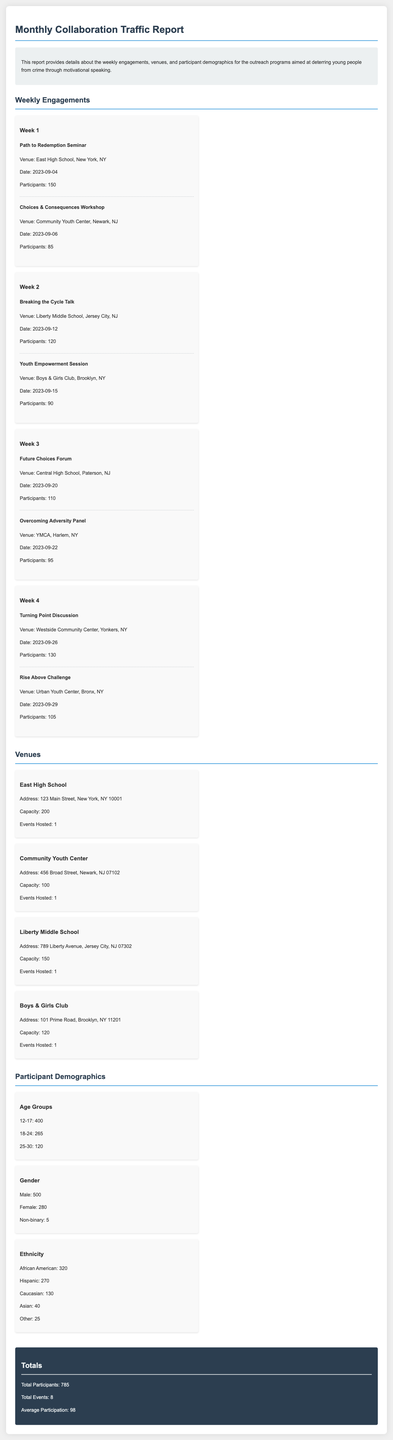What is the total number of participants? The total number of participants is summarized in the Totals section of the report.
Answer: 785 What workshop was held at Community Youth Center? The event name is listed under Week 1 of the Weekly Engagements section.
Answer: Choices & Consequences Workshop In which week was the Future Choices Forum held? Week information is included in the Weekly Engagements section, detailing the events of each week.
Answer: Week 3 How many events were held at Boys & Girls Club? The number of events hosted is mentioned in the Venues section.
Answer: 1 What is the participant demographic for the age group 12-17? The age demographic details can be found in the Participant Demographics section of the report.
Answer: 400 Which venue hosted the most participants? This requires comparison of participants listed under events in the Weekly Engagements section.
Answer: East High School What is the average participation across all events? The average participation is calculated from the total number of participants divided by total events in the Totals section.
Answer: 98 What is the address of Liberty Middle School? The venue's address details are provided in the Venues section.
Answer: 789 Liberty Avenue, Jersey City, NJ 07302 What type of event is the Overcoming Adversity Panel categorized as? The type of event is organized under the weekly engagements and indicates a specific focus.
Answer: Panel 